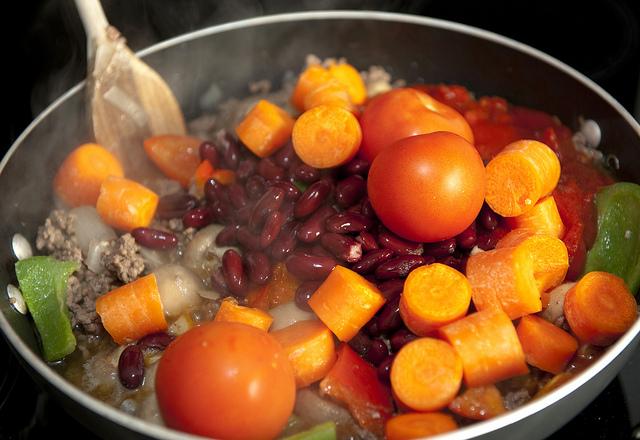Is that kidney beans in the pan?
Write a very short answer. Yes. Is this a vegetarian meal?
Quick response, please. Yes. What is in the pan?
Concise answer only. Vegetables. Is this a breakfast dish?
Keep it brief. No. Are those kidney beans?
Keep it brief. Yes. 